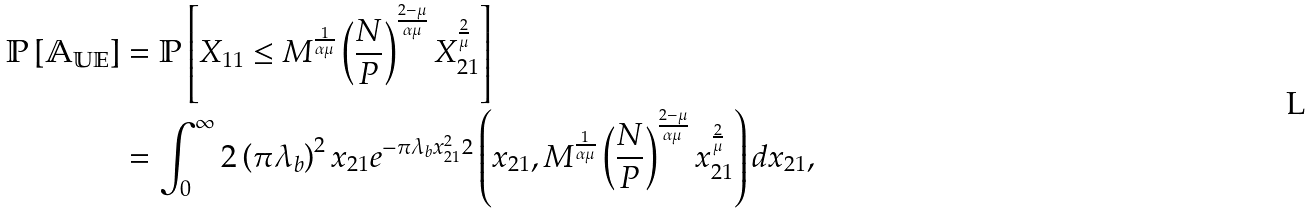<formula> <loc_0><loc_0><loc_500><loc_500>\mathbb { P \left [ A _ { U E } \right ] } & = \mathbb { P } \left [ X _ { 1 1 } \leq M ^ { \frac { 1 } { \alpha \mu } } \left ( \frac { N } { P } \right ) ^ { \frac { 2 - \mu } { \alpha \mu } } X _ { 2 1 } ^ { \frac { 2 } { \mu } } \right ] \\ & = \int _ { 0 } ^ { \infty } 2 \left ( \pi \lambda _ { b } \right ) ^ { 2 } x _ { 2 1 } e ^ { - \pi \lambda _ { b } x _ { 2 1 } ^ { 2 } } { ^ { 2 } } \left ( x _ { 2 1 } , M ^ { \frac { 1 } { \alpha \mu } } \left ( \frac { N } { P } \right ) ^ { \frac { 2 - \mu } { \alpha \mu } } x _ { 2 1 } ^ { \frac { 2 } { \mu } } \right ) d x _ { 2 1 } ,</formula> 